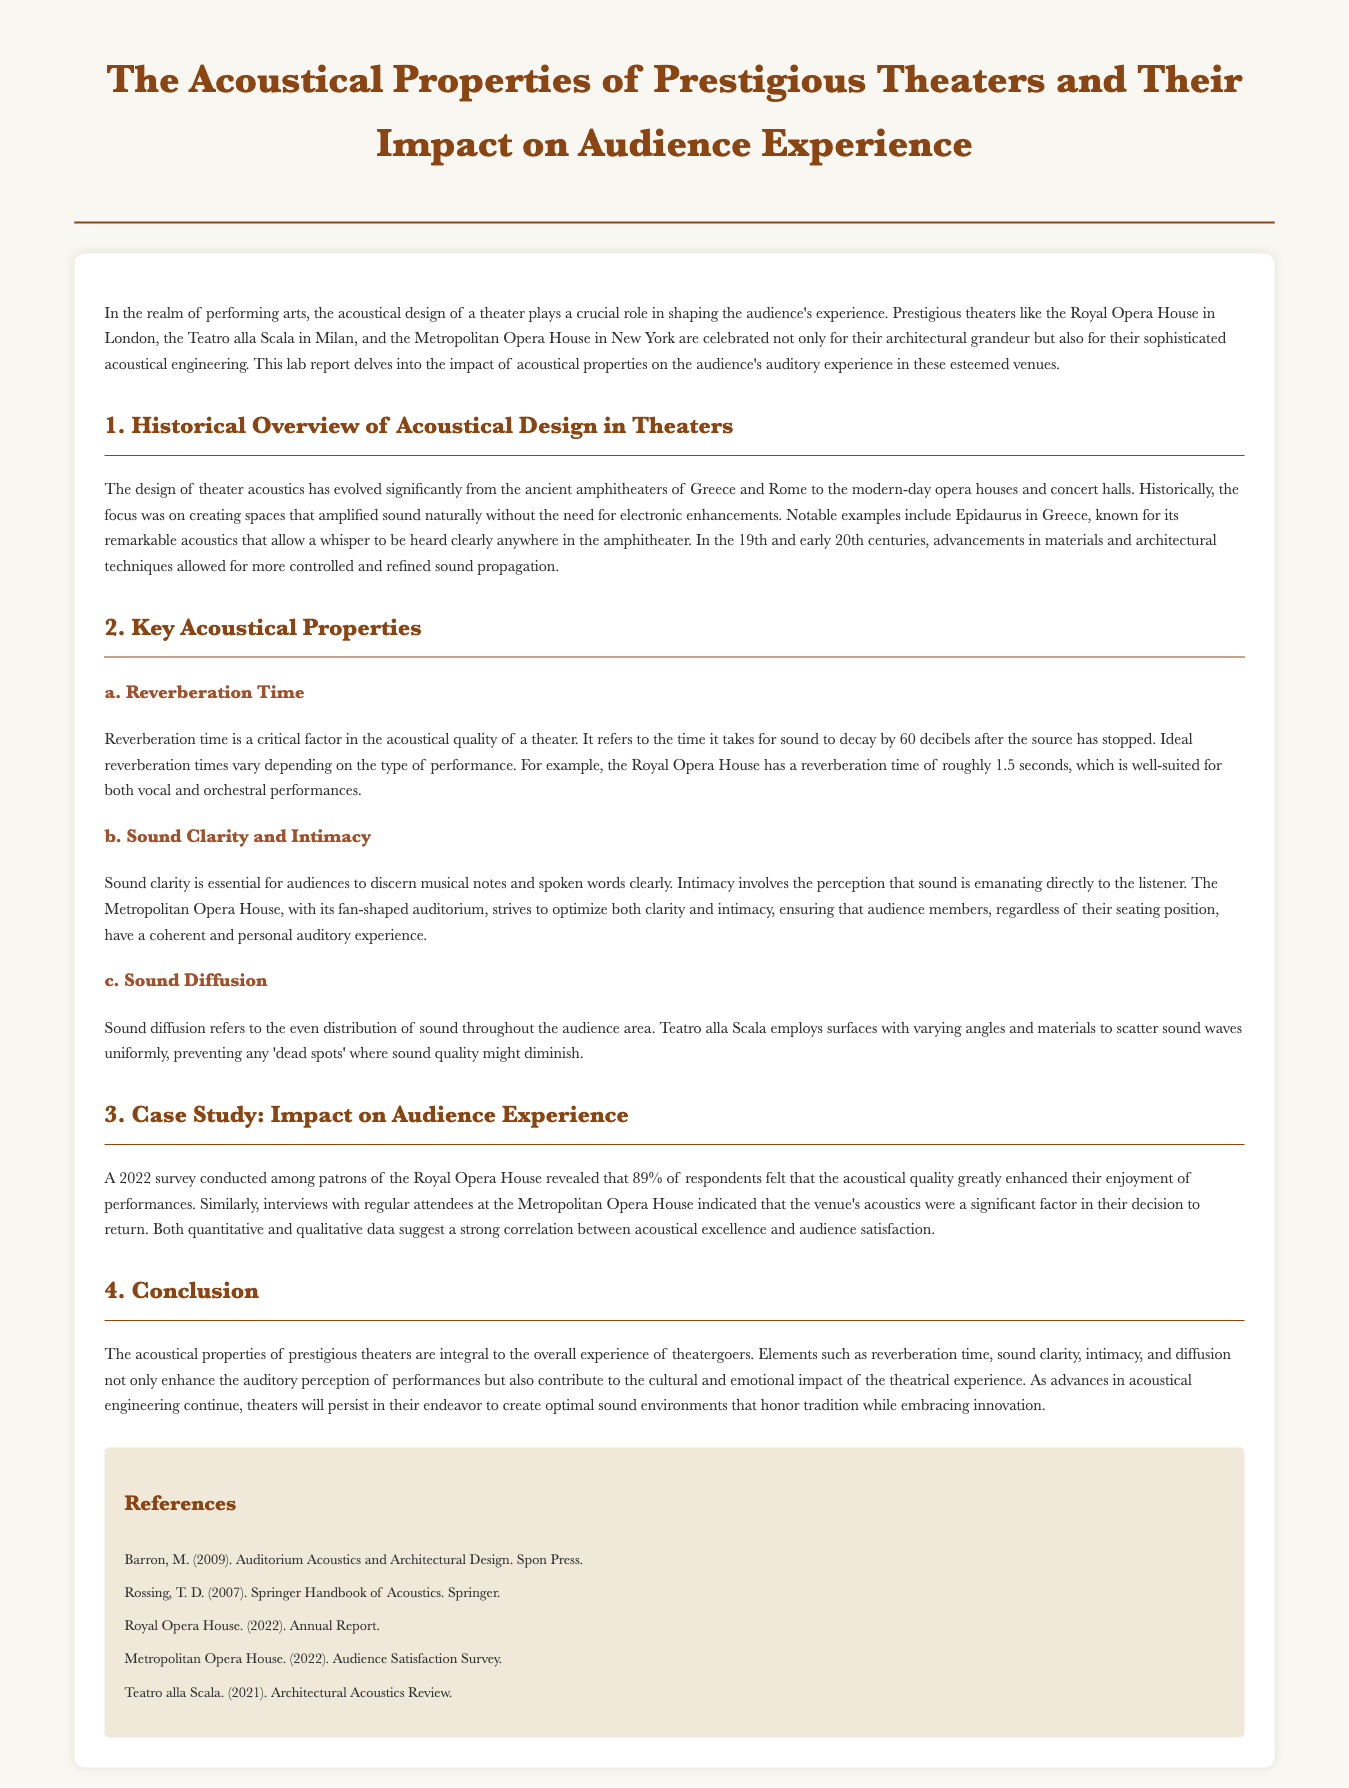What is the main focus of the lab report? The lab report focuses on the acoustical design of theaters and its impact on audience experience.
Answer: Acoustical design of theaters Which theater is known for having a reverberation time of roughly 1.5 seconds? The Royal Opera House has a reverberation time of roughly 1.5 seconds.
Answer: Royal Opera House What percentage of respondents felt that acoustical quality enhanced their enjoyment at the Royal Opera House? 89% of respondents felt that the acoustical quality greatly enhanced their enjoyment of performances.
Answer: 89% What are the three key acoustical properties discussed in the report? The three key acoustical properties are reverberation time, sound clarity and intimacy, and sound diffusion.
Answer: Reverberation time, sound clarity and intimacy, sound diffusion What historical period saw advancements in materials and architectural techniques for theater acoustics? The advancements occurred in the 19th and early 20th centuries.
Answer: 19th and early 20th centuries Which opera house uses a fan-shaped auditorium for sound clarity and intimacy? The Metropolitan Opera House uses a fan-shaped auditorium.
Answer: Metropolitan Opera House What type of data suggests a correlation between acoustical excellence and audience satisfaction? Both quantitative and qualitative data suggest a strong correlation.
Answer: Quantitative and qualitative data Who authored the reference titled "Auditorium Acoustics and Architectural Design"? The reference was authored by M. Barron.
Answer: M. Barron 